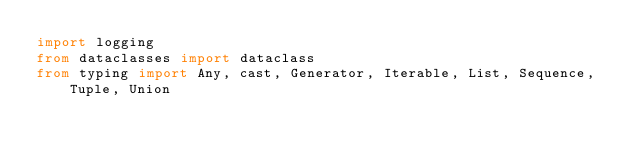Convert code to text. <code><loc_0><loc_0><loc_500><loc_500><_Python_>import logging
from dataclasses import dataclass
from typing import Any, cast, Generator, Iterable, List, Sequence, Tuple, Union
</code> 